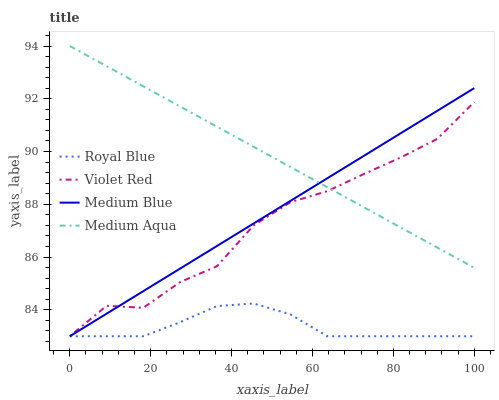Does Royal Blue have the minimum area under the curve?
Answer yes or no. Yes. Does Medium Aqua have the maximum area under the curve?
Answer yes or no. Yes. Does Violet Red have the minimum area under the curve?
Answer yes or no. No. Does Violet Red have the maximum area under the curve?
Answer yes or no. No. Is Medium Blue the smoothest?
Answer yes or no. Yes. Is Violet Red the roughest?
Answer yes or no. Yes. Is Royal Blue the smoothest?
Answer yes or no. No. Is Royal Blue the roughest?
Answer yes or no. No. Does Royal Blue have the lowest value?
Answer yes or no. Yes. Does Medium Aqua have the highest value?
Answer yes or no. Yes. Does Violet Red have the highest value?
Answer yes or no. No. Is Royal Blue less than Medium Aqua?
Answer yes or no. Yes. Is Medium Aqua greater than Royal Blue?
Answer yes or no. Yes. Does Violet Red intersect Medium Blue?
Answer yes or no. Yes. Is Violet Red less than Medium Blue?
Answer yes or no. No. Is Violet Red greater than Medium Blue?
Answer yes or no. No. Does Royal Blue intersect Medium Aqua?
Answer yes or no. No. 